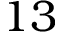Convert formula to latex. <formula><loc_0><loc_0><loc_500><loc_500>1 3</formula> 